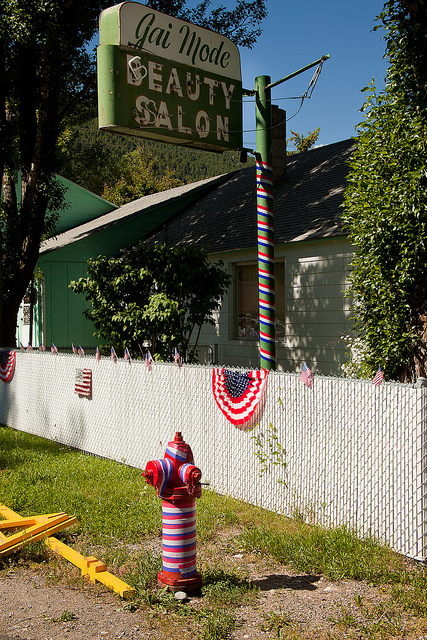Read and extract the text from this image. gai mode BEAUTY SALON 